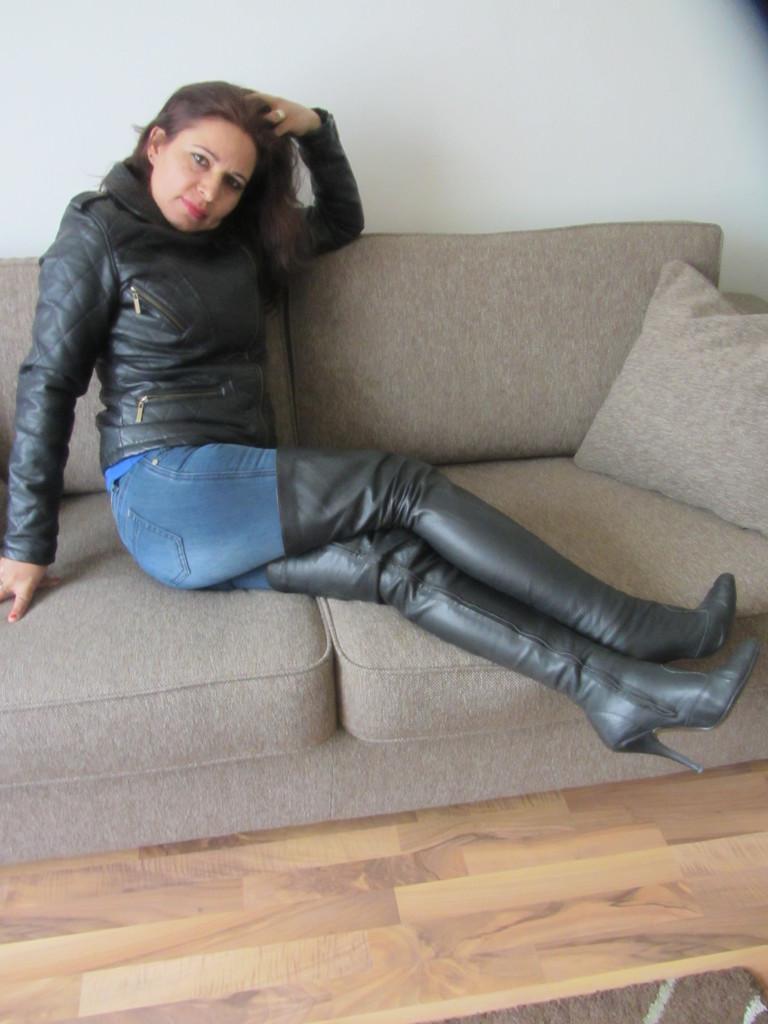Describe this image in one or two sentences. In the image a woman is sitting on a couch. Behind the couch there is wall. 